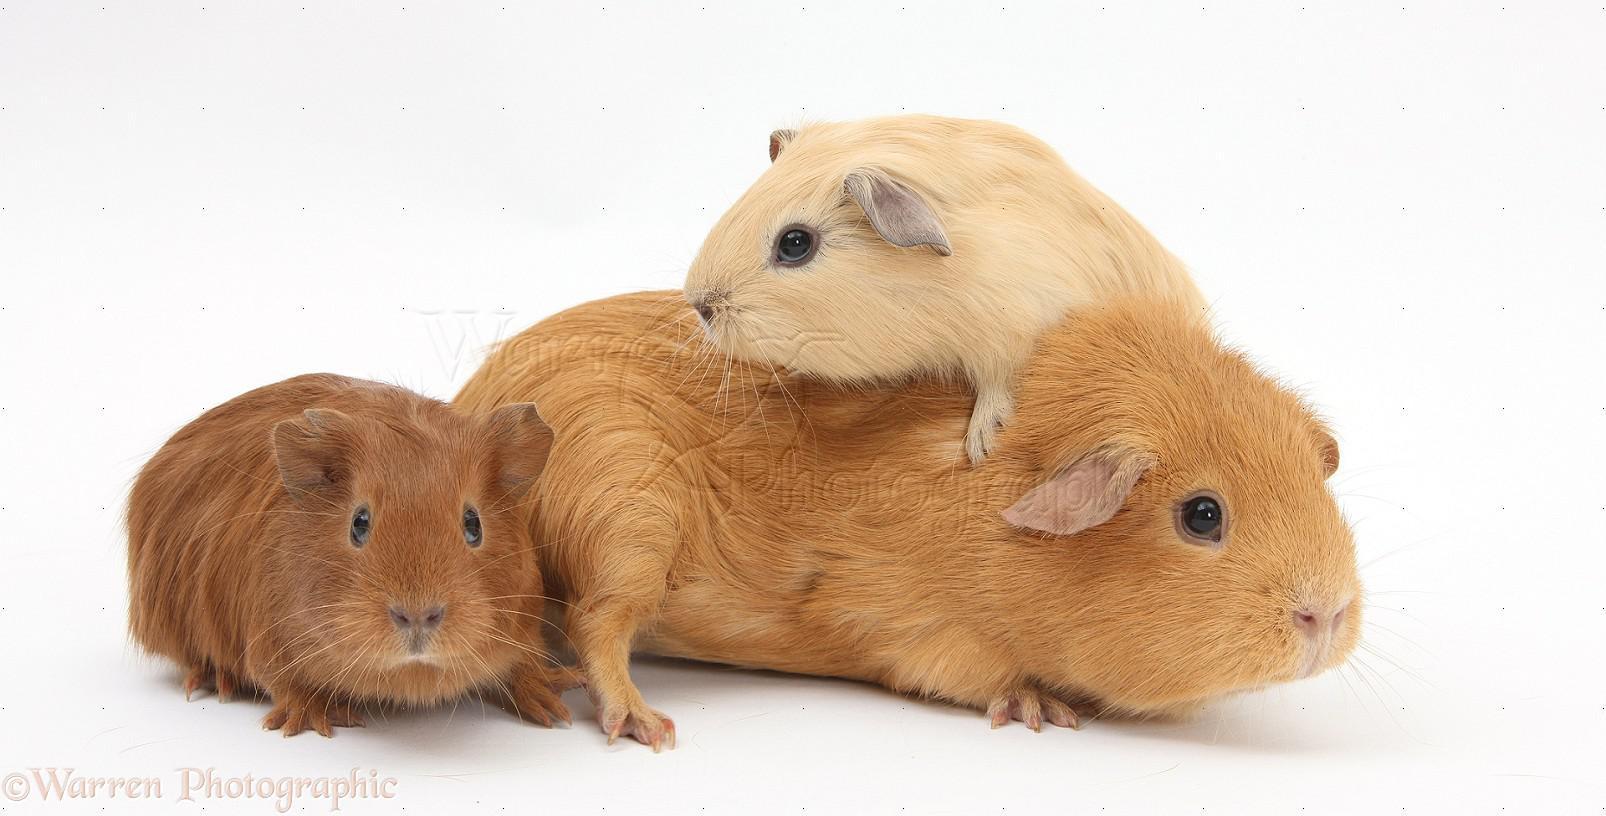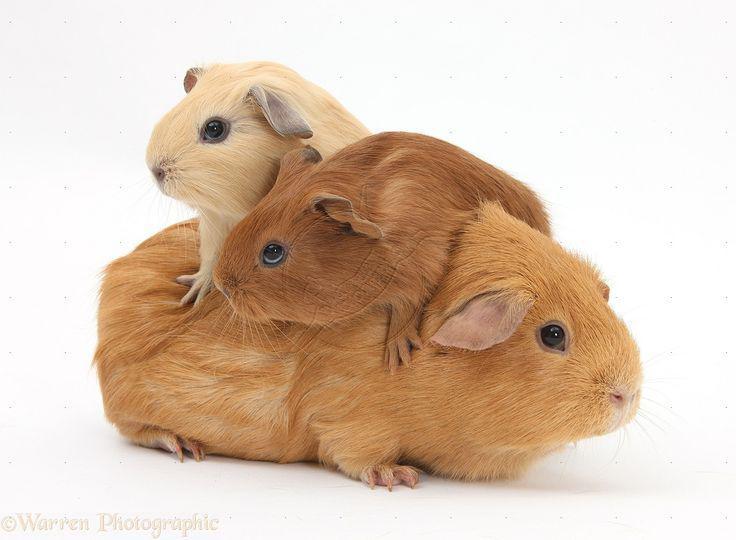The first image is the image on the left, the second image is the image on the right. Assess this claim about the two images: "The right image has three guinea pigs.". Correct or not? Answer yes or no. Yes. The first image is the image on the left, the second image is the image on the right. For the images displayed, is the sentence "All of the animals are a type of guinea pig and none of them are sitting on top of each other." factually correct? Answer yes or no. No. 